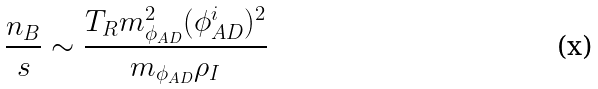<formula> <loc_0><loc_0><loc_500><loc_500>\frac { n _ { B } } { s } \sim \frac { T _ { R } m _ { \phi _ { A D } } ^ { 2 } ( \phi _ { A D } ^ { i } ) ^ { 2 } } { m _ { \phi _ { A D } } \rho _ { I } }</formula> 